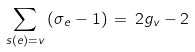<formula> <loc_0><loc_0><loc_500><loc_500>\sum _ { s ( e ) = v } \, ( \sigma _ { e } - 1 ) \, = \, 2 g _ { v } - 2</formula> 